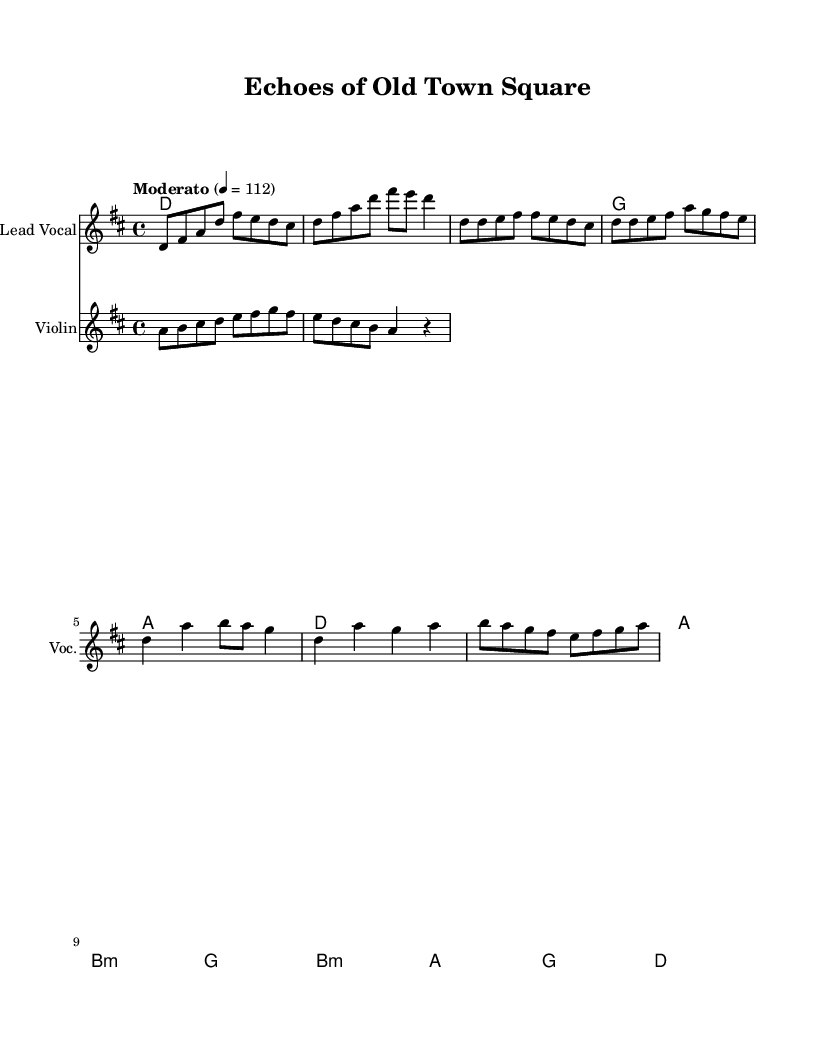What is the key signature of this music? The key signature is D major, which has two sharps (F# and C#). You can determine this by looking at the beginning of the staff, where the sharps are indicated.
Answer: D major What is the time signature of this music? The time signature is 4/4, which means there are four beats in each measure and the quarter note gets one beat. This is visibly noted at the start of the music.
Answer: 4/4 What is the tempo marking for this piece? The tempo marking is "Moderato," indicating a moderate speed. This is explicitly stated in the score as the tempo indication.
Answer: Moderato How many measures are there in the chorus section? The chorus consists of four measures. You can count the measures based on the bar lines that separate the music into distinct sections.
Answer: 4 What type of harmony is used in the chorus? The harmony in the chorus includes a B minor chord. This is noted in the chord names under the staff, where the chord changes for that section are indicated.
Answer: B minor What instrument provides a folk-inspired melody? The instrument that provides a folk-inspired melody is the violin, which is specified in the score. The violin part is clearly labeled underneath the lead vocal staff.
Answer: Violin What is the first note of the melody in the intro? The first note of the melody in the intro is D. This can be found by examining the first note of the melody line indicated in the sheet music.
Answer: D 